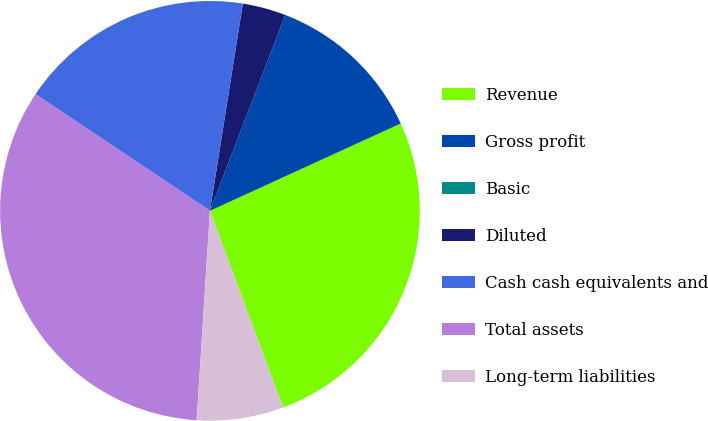<chart> <loc_0><loc_0><loc_500><loc_500><pie_chart><fcel>Revenue<fcel>Gross profit<fcel>Basic<fcel>Diluted<fcel>Cash cash equivalents and<fcel>Total assets<fcel>Long-term liabilities<nl><fcel>26.17%<fcel>12.32%<fcel>0.0%<fcel>3.34%<fcel>18.13%<fcel>33.37%<fcel>6.67%<nl></chart> 